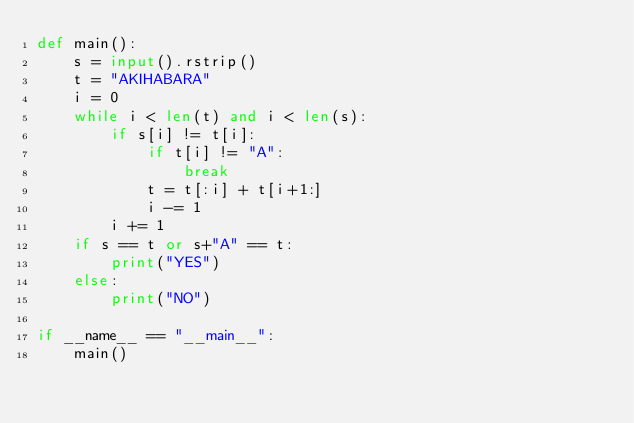<code> <loc_0><loc_0><loc_500><loc_500><_Python_>def main():
    s = input().rstrip()
    t = "AKIHABARA"
    i = 0
    while i < len(t) and i < len(s):
        if s[i] != t[i]:
            if t[i] != "A":
                break
            t = t[:i] + t[i+1:]
            i -= 1
        i += 1
    if s == t or s+"A" == t:
        print("YES")
    else:
        print("NO")

if __name__ == "__main__":
    main()
</code> 